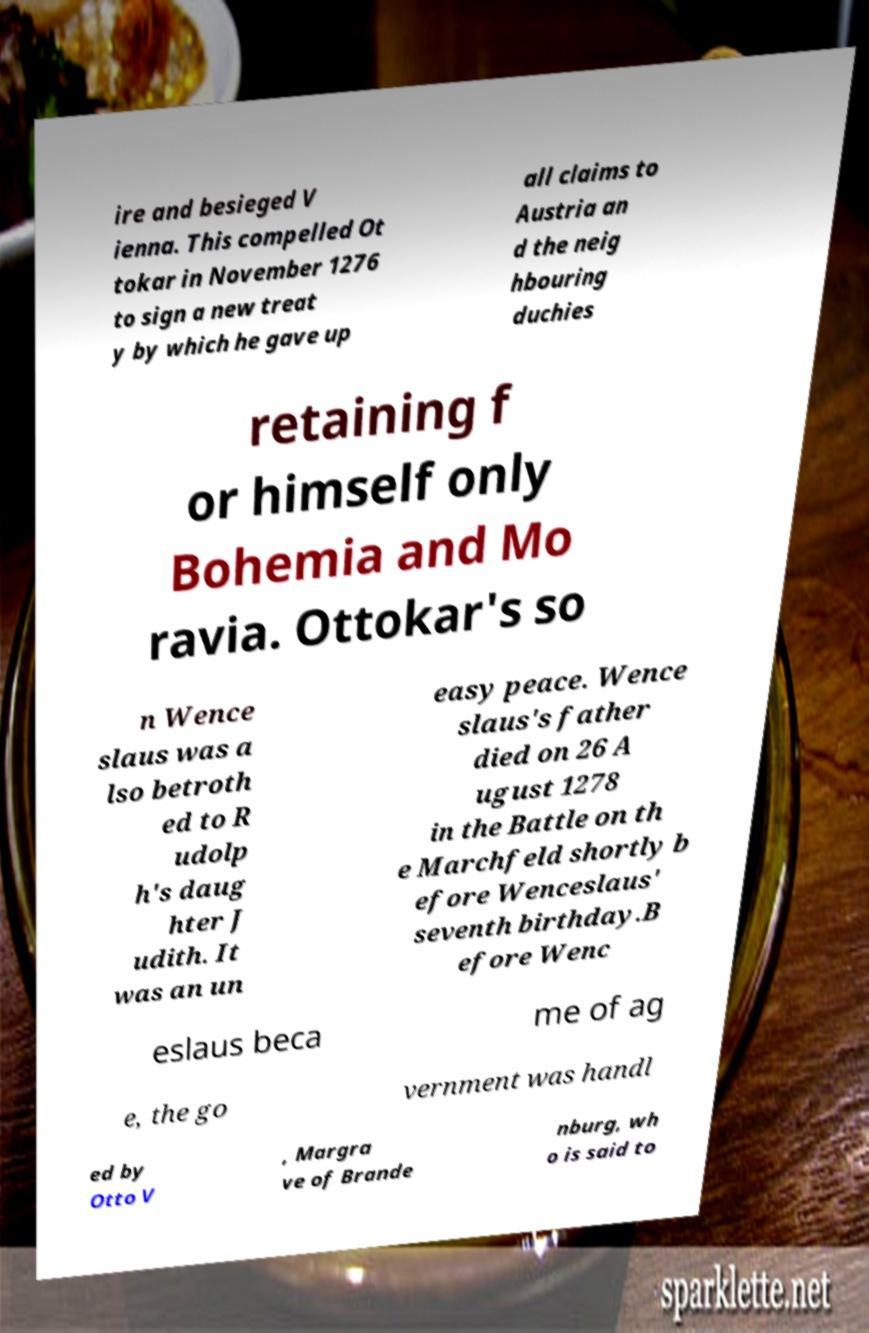Could you extract and type out the text from this image? ire and besieged V ienna. This compelled Ot tokar in November 1276 to sign a new treat y by which he gave up all claims to Austria an d the neig hbouring duchies retaining f or himself only Bohemia and Mo ravia. Ottokar's so n Wence slaus was a lso betroth ed to R udolp h's daug hter J udith. It was an un easy peace. Wence slaus's father died on 26 A ugust 1278 in the Battle on th e Marchfeld shortly b efore Wenceslaus' seventh birthday.B efore Wenc eslaus beca me of ag e, the go vernment was handl ed by Otto V , Margra ve of Brande nburg, wh o is said to 